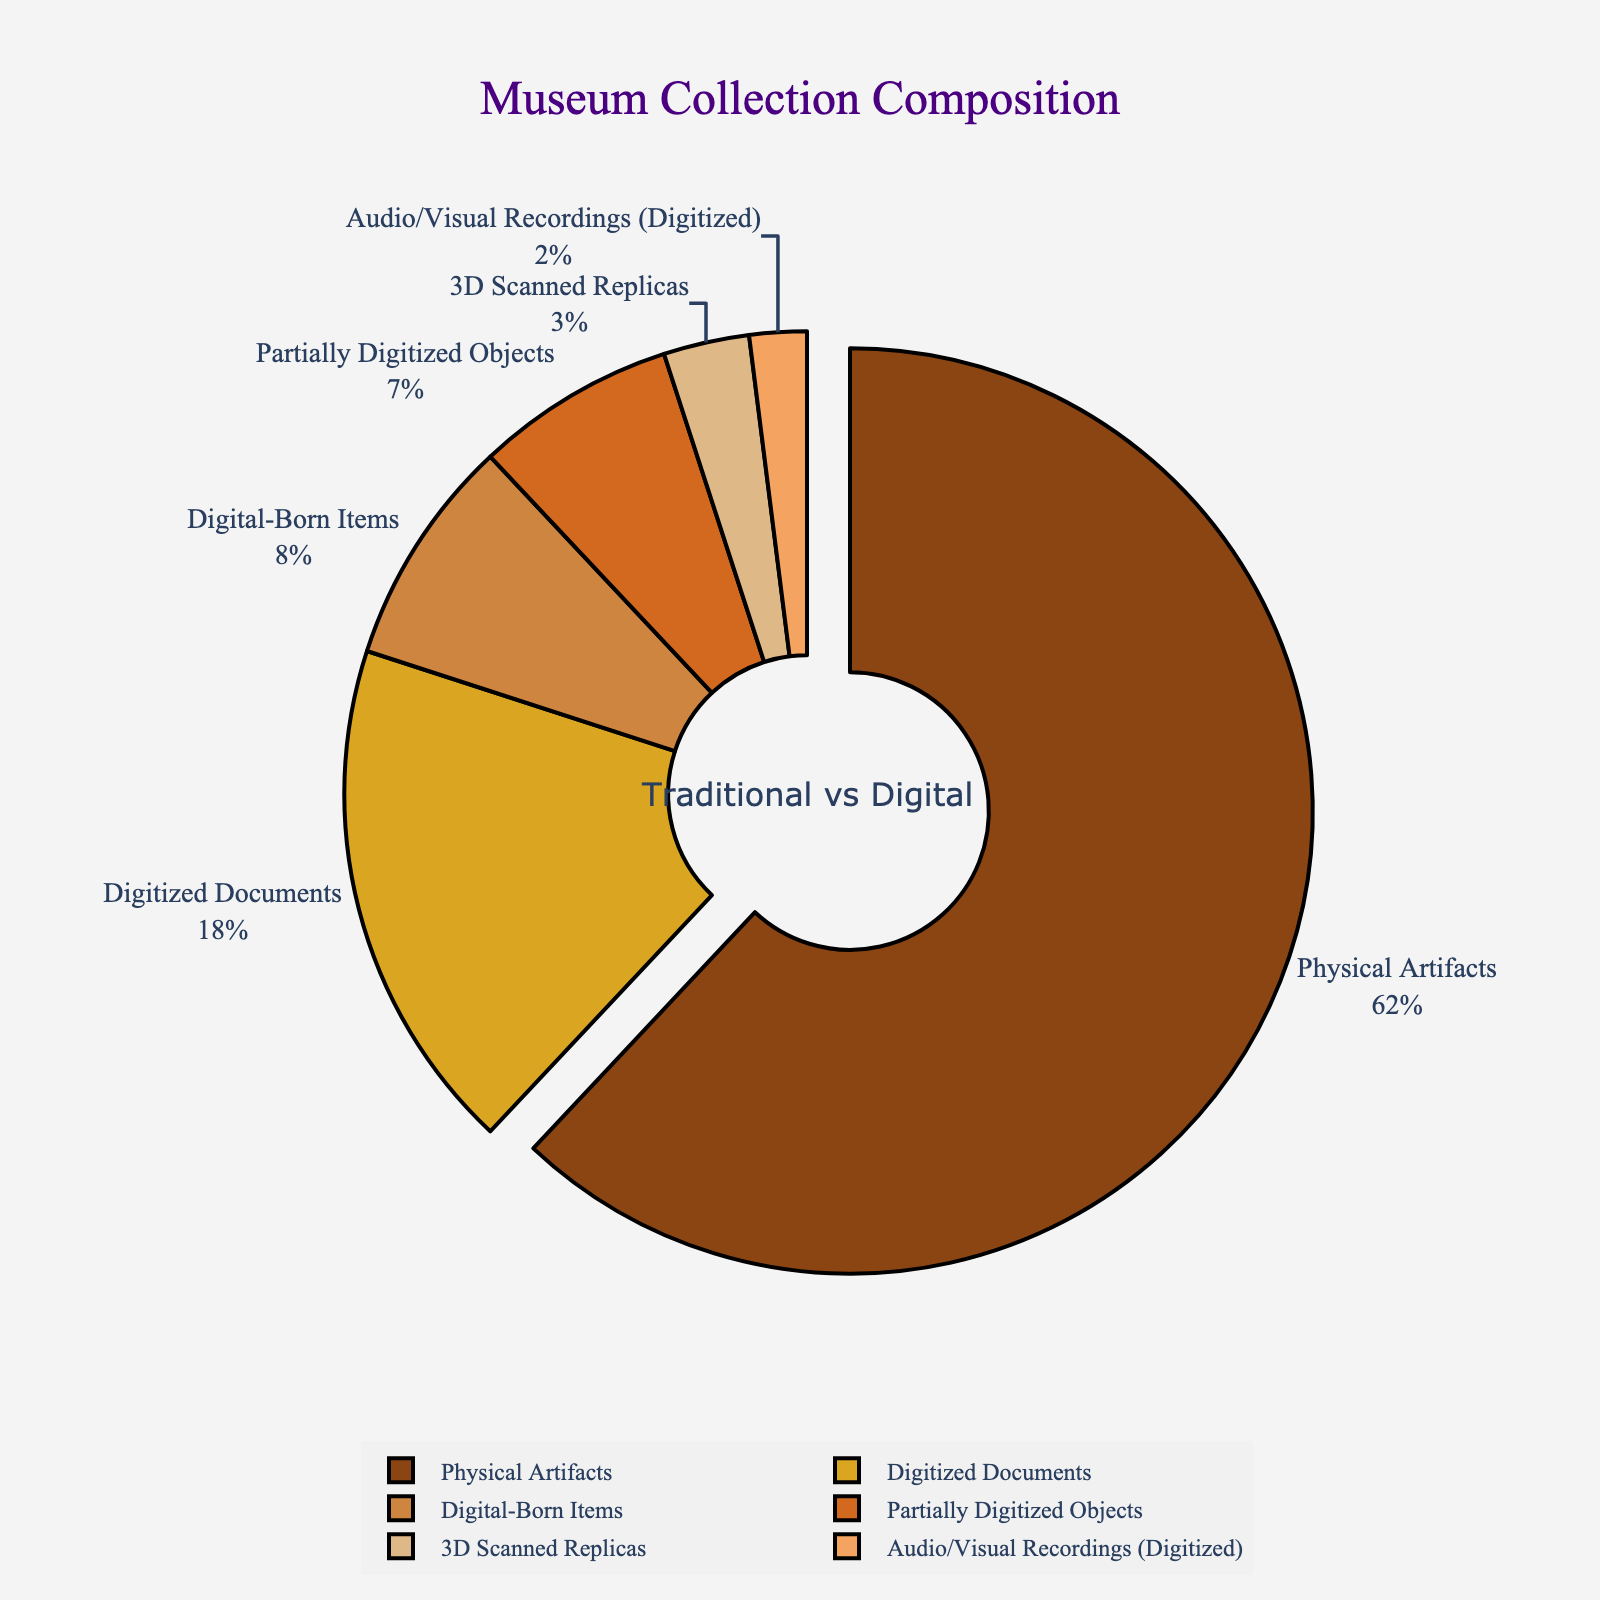what percentage of items in the museum collections are fully digitized? The category "Digitized Documents" represents items that are fully digitized. According to the figure, "Digitized Documents" account for 18% of the museum collections.
Answer: 18% how much more significant is the portion of physical artifacts compared to 3D scanned replicas? Based on the figure, "Physical Artifacts" make up 62% of the collection, while "3D Scanned Replicas" constitute 3%. The difference can be calculated as 62% - 3% = 59%.
Answer: 59% are there more digital-born items or audio/visual recordings (digitized)? According to the figure, "Digital-Born Items" constitute 8% of the collection, whereas "Audio/Visual Recordings (Digitized)" make up 2%. Since 8% is greater than 2%, there are more digital-born items.
Answer: digital-born items what is the combined percentage of digitized and partially digitized objects? The categories "Digitized Documents" and "Partially Digitized Objects" represent these two groups. Their percentages are 18% and 7%, respectively. The combined percentage is 18% + 7% = 25%.
Answer: 25% which category is visually highlighted in the figure? The figure visually highlights one category by pulling it slightly from the center. "Physical Artifacts" is the category that is pulled out.
Answer: physical artifacts if digital-born items doubled their percentage, what would the new percentage be? The current percentage of digital-born items is 8%. If this doubled, the new percentage would be 8% * 2 = 16%.
Answer: 16% which category has the smallest share in the museum collections? The smallest share is represented by "Audio/Visual Recordings (Digitized)" which constitutes 2% of the museum collections.
Answer: audio/visual recordings (digitized) what is the difference in representation between digitized documents and physical artifacts? "Digitized Documents" account for 18% and "Physical Artifacts" make up 62% of the collection. The difference is 62% - 18% = 44%.
Answer: 44% 